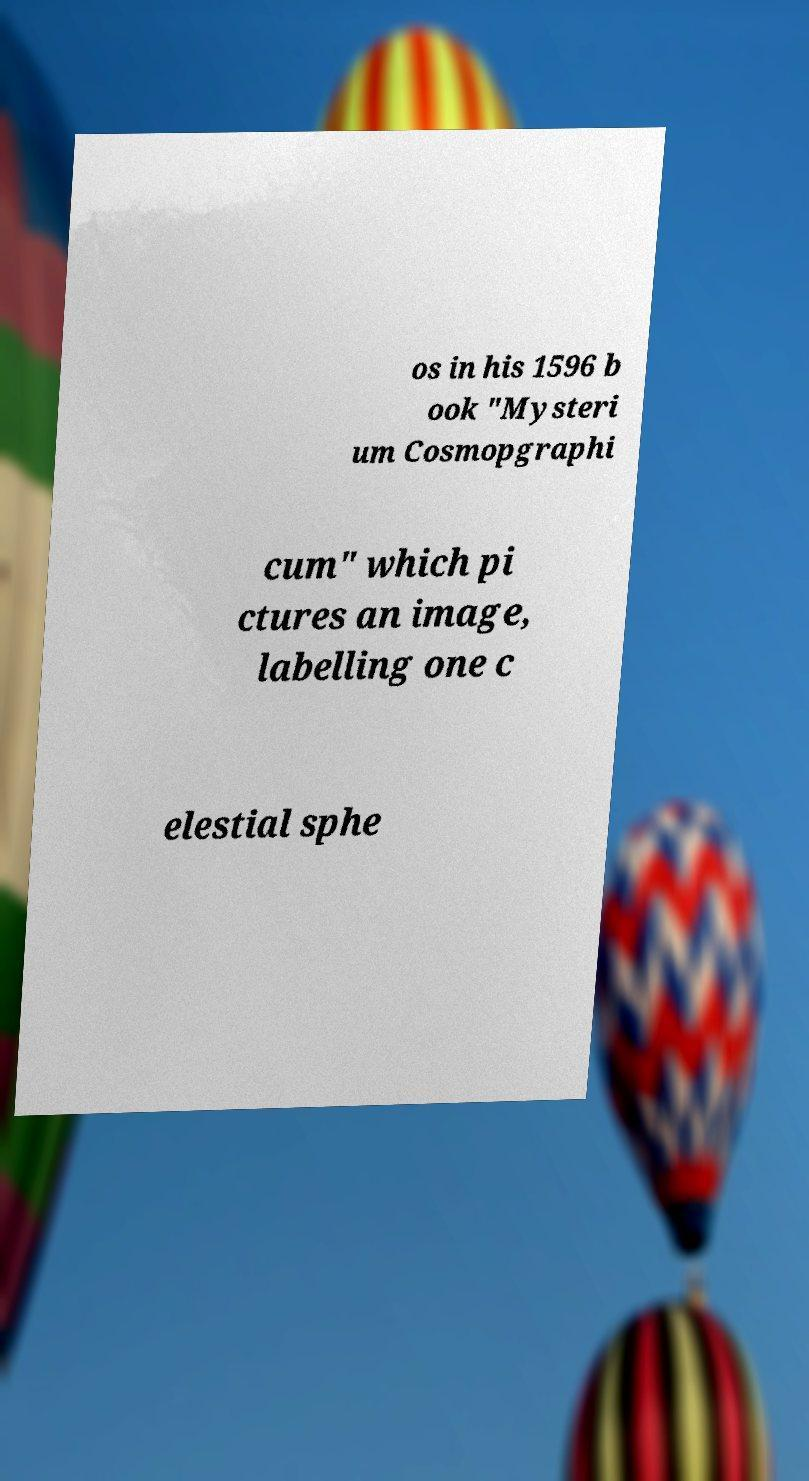For documentation purposes, I need the text within this image transcribed. Could you provide that? os in his 1596 b ook "Mysteri um Cosmopgraphi cum" which pi ctures an image, labelling one c elestial sphe 